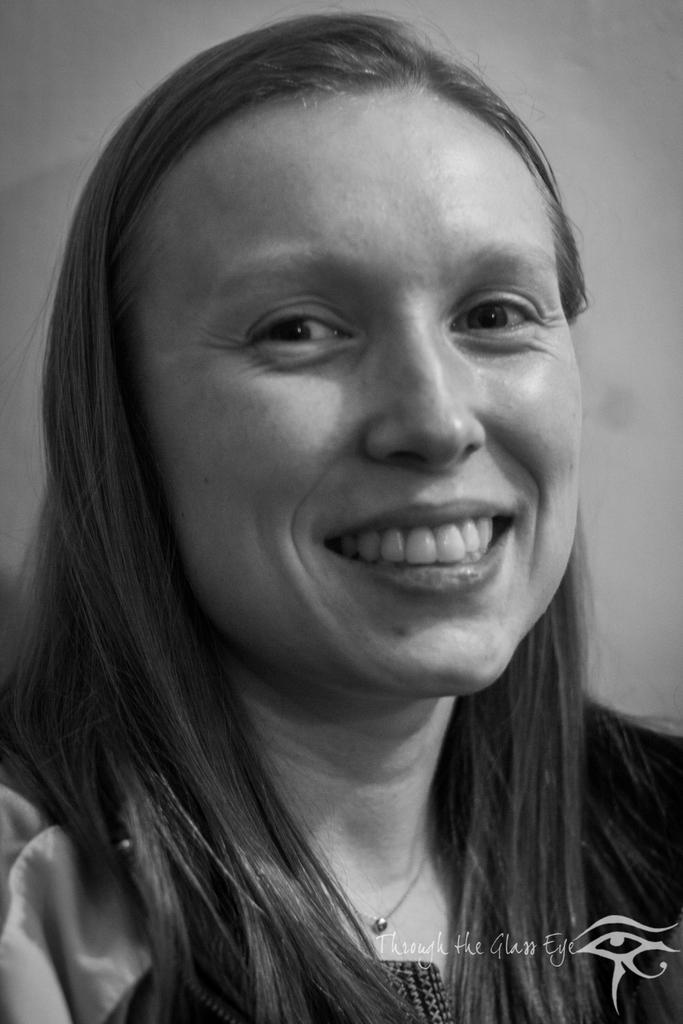What is the color scheme of the image? The image is black and white. Who is present in the image? There is a woman in the image. What is the woman's expression? The woman is smiling. What can be seen in the background of the image? There is a wall in the background of the image. How many clocks are hanging on the wall in the image? There are no clocks visible in the image; it only shows a woman and a wall in the background. What type of lettuce is the woman holding in the image? There is no lettuce present in the image; the woman is not holding any object. 